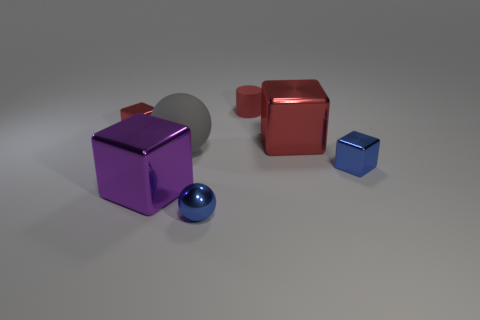Do the blue metal thing that is to the left of the small rubber thing and the small thing that is behind the small red cube have the same shape? no 